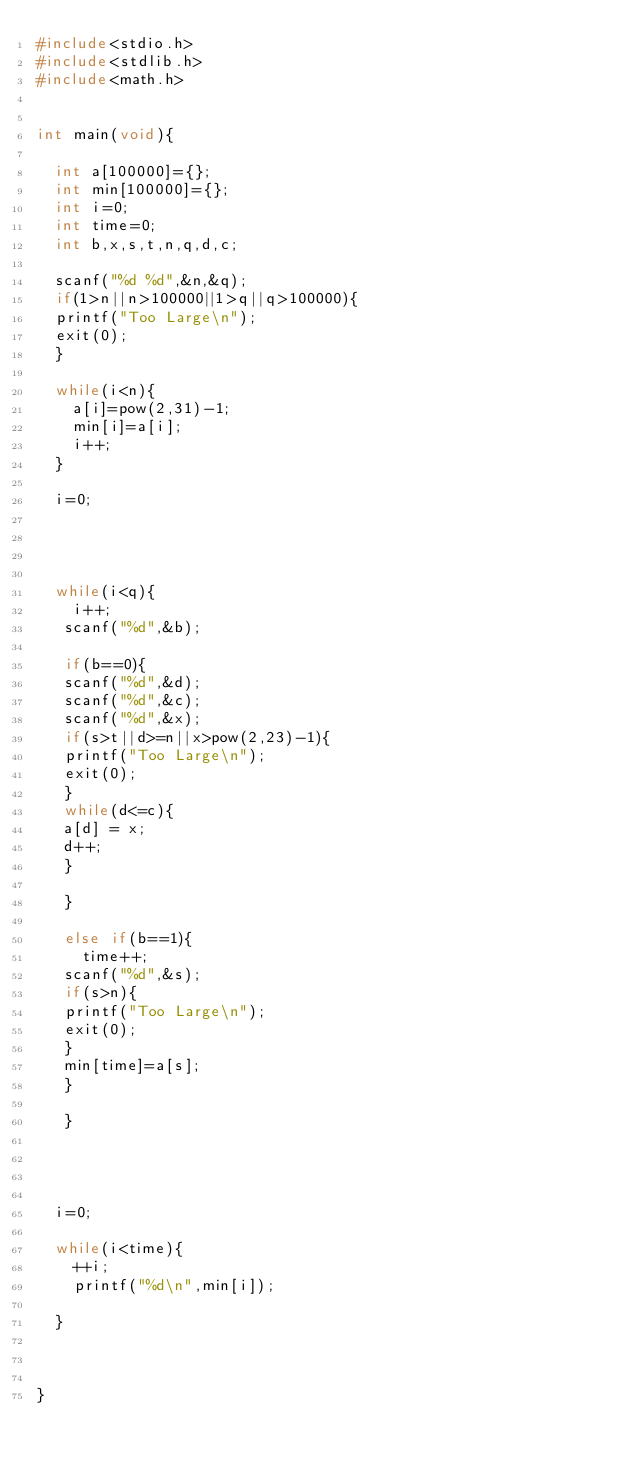Convert code to text. <code><loc_0><loc_0><loc_500><loc_500><_C_>#include<stdio.h>
#include<stdlib.h>
#include<math.h>


int main(void){

  int a[100000]={};
  int min[100000]={};
  int i=0;  
  int time=0;
  int b,x,s,t,n,q,d,c;

  scanf("%d %d",&n,&q);
  if(1>n||n>100000||1>q||q>100000){
  printf("Too Large\n");
  exit(0);
  }

  while(i<n){
    a[i]=pow(2,31)-1;
    min[i]=a[i];
    i++;
  }

  i=0;




  while(i<q){
    i++;
   scanf("%d",&b);

   if(b==0){
   scanf("%d",&d);
   scanf("%d",&c);
   scanf("%d",&x);
   if(s>t||d>=n||x>pow(2,23)-1){
   printf("Too Large\n");
   exit(0);
   }
   while(d<=c){
   a[d] = x;
   d++;
   }

   }
 
   else if(b==1){
     time++;
   scanf("%d",&s);
   if(s>n){
   printf("Too Large\n");
   exit(0);
   }
   min[time]=a[s];
   }

   }


  

  i=0;

  while(i<time){
    ++i;
    printf("%d\n",min[i]);

  }
  


}</code> 